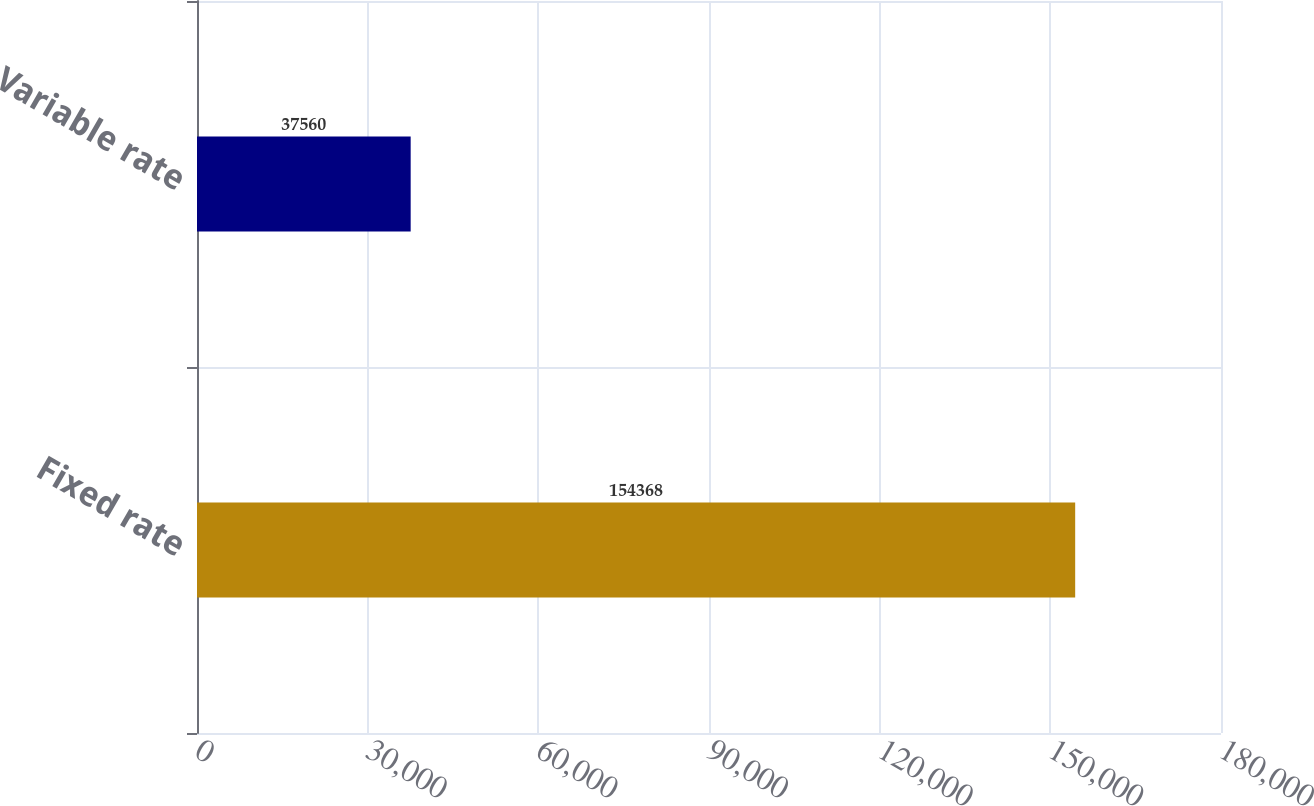Convert chart. <chart><loc_0><loc_0><loc_500><loc_500><bar_chart><fcel>Fixed rate<fcel>Variable rate<nl><fcel>154368<fcel>37560<nl></chart> 